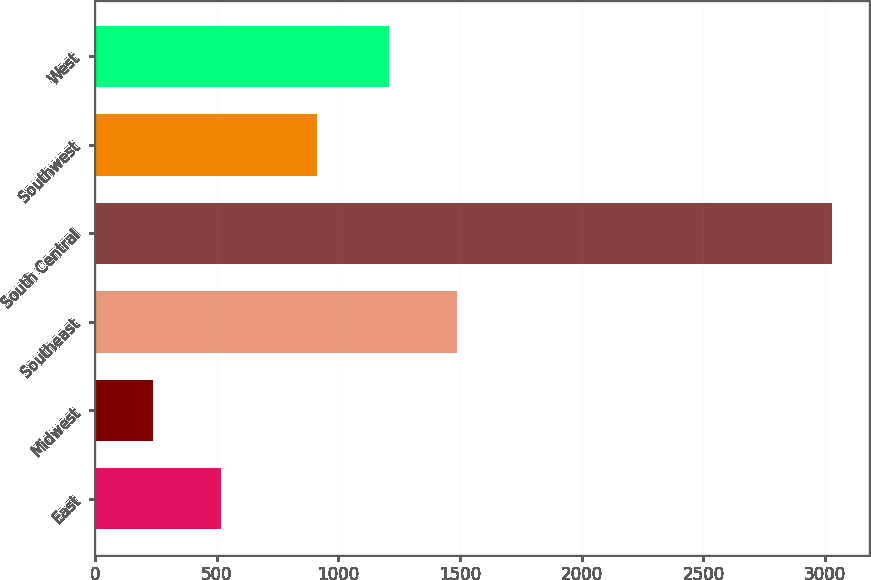Convert chart. <chart><loc_0><loc_0><loc_500><loc_500><bar_chart><fcel>East<fcel>Midwest<fcel>Southeast<fcel>South Central<fcel>Southwest<fcel>West<nl><fcel>518.9<fcel>240<fcel>1485.9<fcel>3029<fcel>913<fcel>1207<nl></chart> 